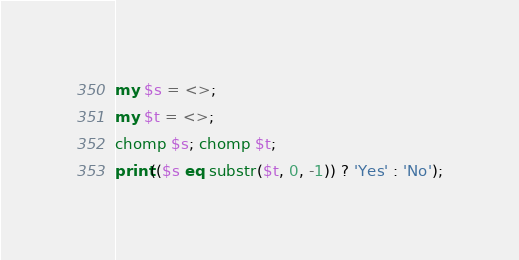<code> <loc_0><loc_0><loc_500><loc_500><_Perl_>my $s = <>;
my $t = <>;
chomp $s; chomp $t;
print(($s eq substr($t, 0, -1)) ? 'Yes' : 'No');</code> 